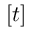<formula> <loc_0><loc_0><loc_500><loc_500>[ t ]</formula> 